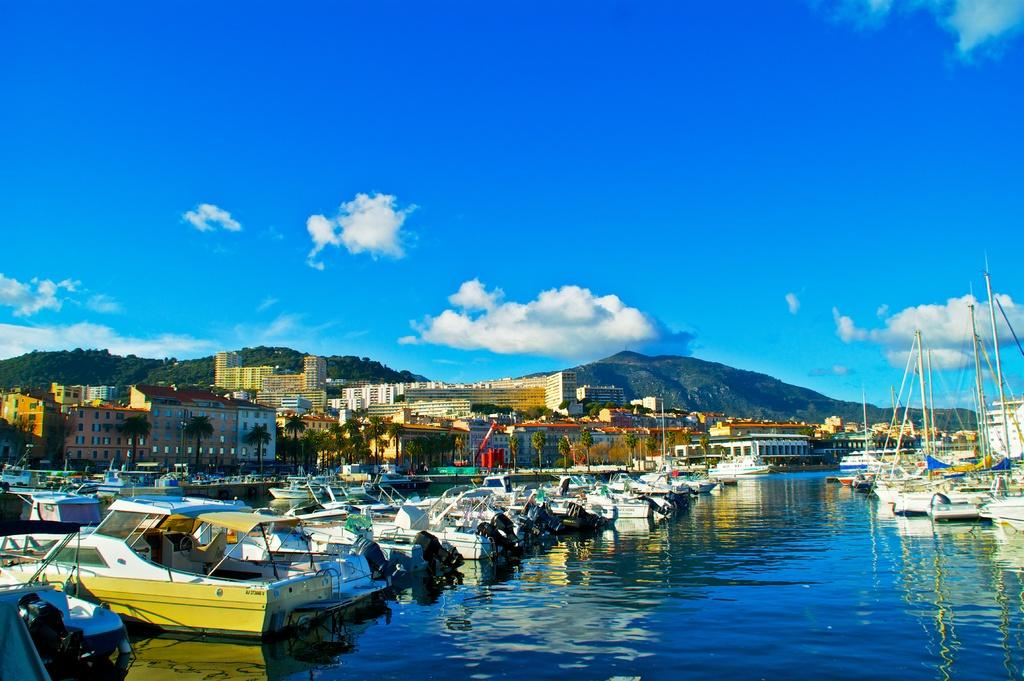What types of watercraft are visible in the image? There are ships and boats in the image. Where are the ships and boats located? The ships and boats are on the water. What can be seen in the background of the image? In the background of the image, there are poles, buildings, trees, objects, mountains, and clouds in the sky. What type of tramp is visible in the image? There is no tramp present in the image. Can you tell me where the church is located in the image? There is no church present in the image. 